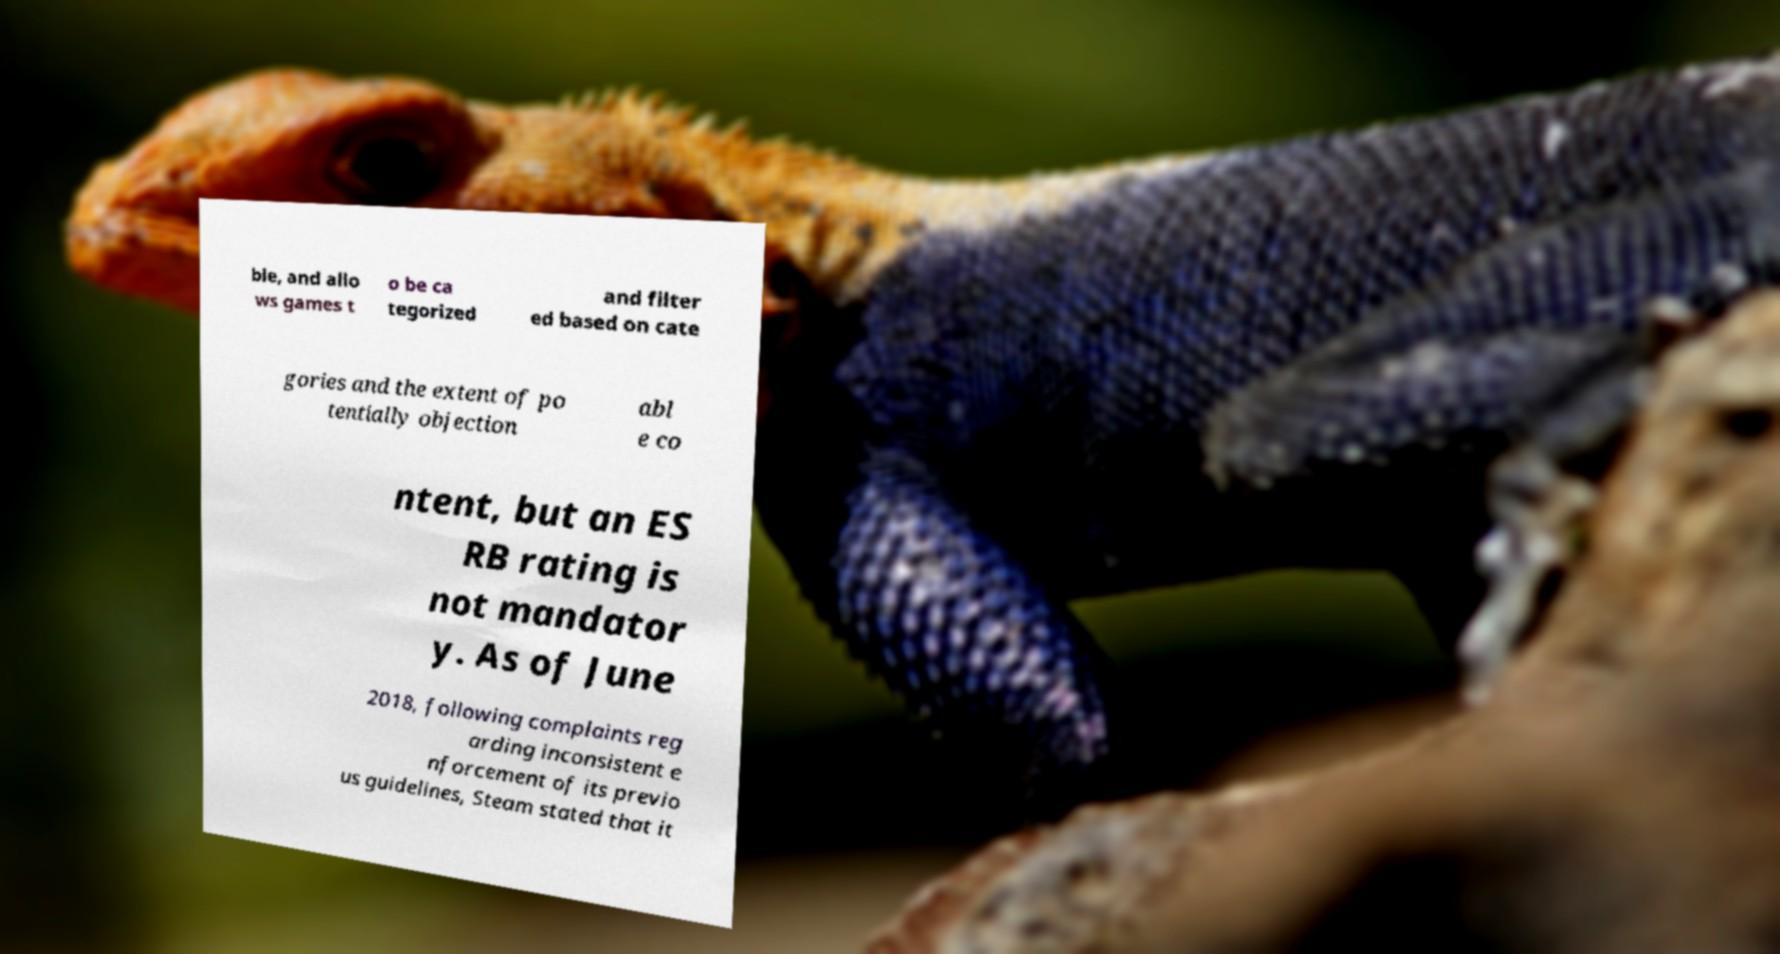Please read and relay the text visible in this image. What does it say? ble, and allo ws games t o be ca tegorized and filter ed based on cate gories and the extent of po tentially objection abl e co ntent, but an ES RB rating is not mandator y. As of June 2018, following complaints reg arding inconsistent e nforcement of its previo us guidelines, Steam stated that it 